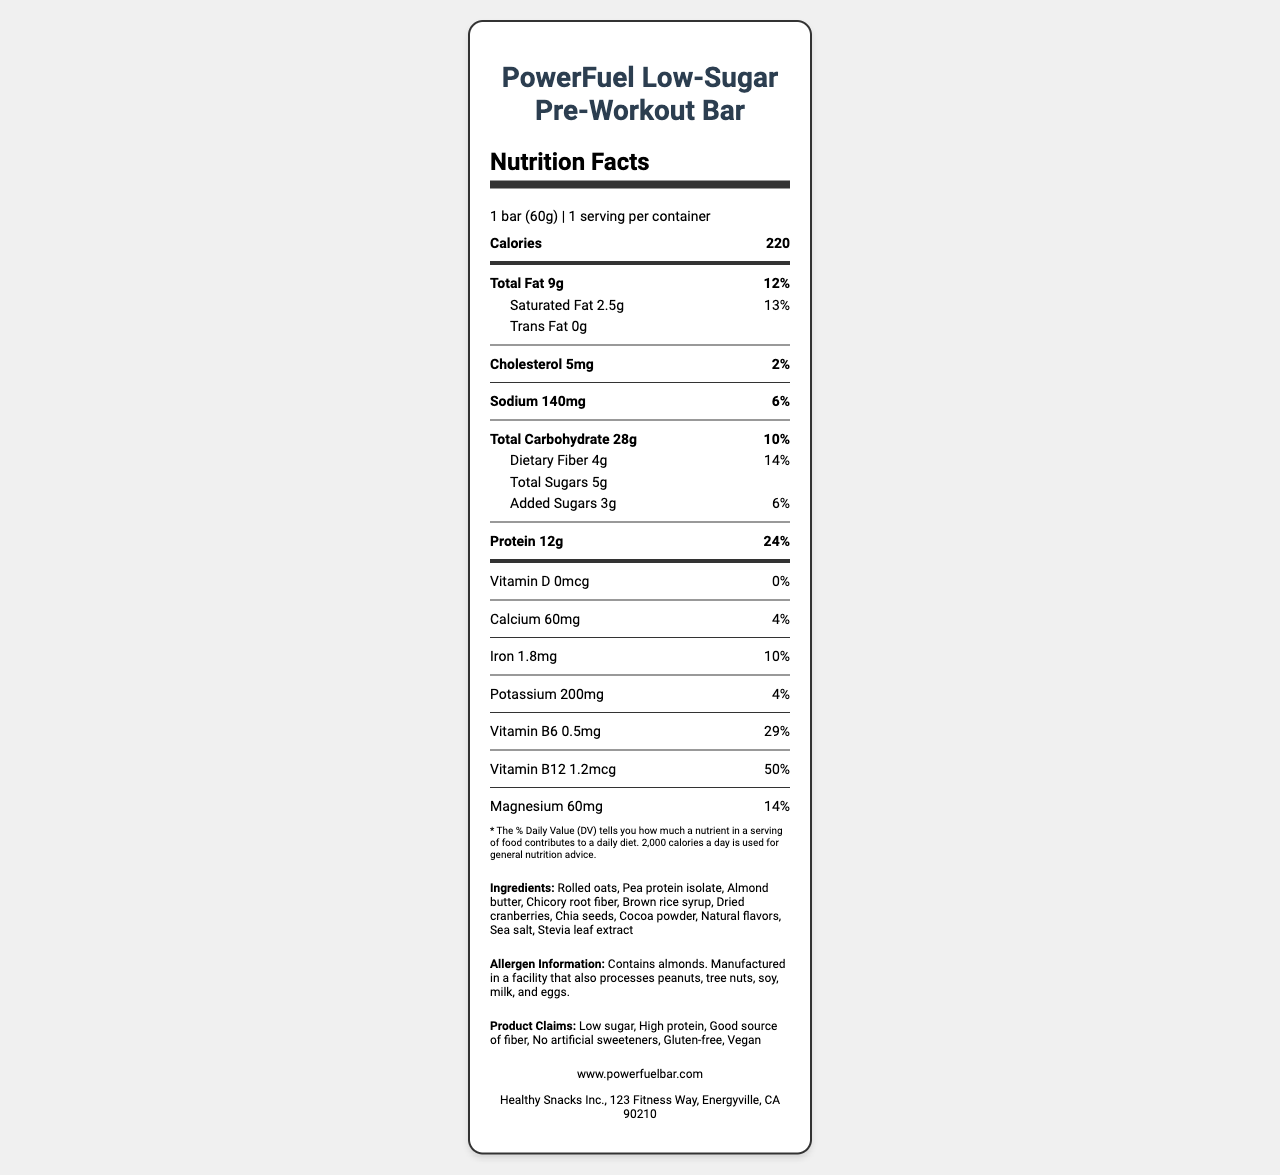what is the serving size? The serving size is specified in the document as "1 bar (60g)".
Answer: 1 bar (60g) how many calories are in one serving? The document states that there are 220 calories per serving.
Answer: 220 what is the amount of protein per serving? The document lists the protein content as 12g per serving.
Answer: 12g what percentage of the daily value for Vitamin B12 does one serving provide? According to the document, one serving provides 50% of the daily value for Vitamin B12.
Answer: 50% what are the main sources of fat in this product? The ingredients list includes almond butter and chia seeds which are common sources of fats.
Answer: Almond butter, Chia seeds which of the following is not an ingredient in the PowerFuel bar? A. Rolled oats B. Pea protein isolate C. Honey D. Stevia leaf extract Honey is not listed as an ingredient; all other options are listed.
Answer: C. Honey how much cholesterol is in one serving? A. 0mg B. 5mg C. 10mg D. 20mg The document states that one serving contains 5mg of cholesterol.
Answer: B. 5mg does the product contain any artificial sweeteners? The marketing claims specifically state "No artificial sweeteners".
Answer: No is this product gluten-free? The marketing claims include "Gluten-free".
Answer: Yes summarize the nutritional highlights of the PowerFuel Low-Sugar Pre-Workout Bar. The document shows that the product is designed to be a nutritious energy bar with low sugar, high protein, and beneficial for pre-workout consumption. It's highlighted as gluten-free, vegan, and lacking artificial sweeteners.
Answer: The PowerFuel Low-Sugar Pre-Workout Bar contains 220 calories per serving, with 9g of total fat, 28g of total carbohydrates, and 12g of protein. It's low in sugar with only 5g of total sugars, includes key vitamins and minerals like Vitamin B12 (50% DV) and Magnesium (14% DV), and is gluten-free, vegan, and contains no artificial sweeteners. does the product contain sodium? The document shows that the product contains 140mg of sodium per serving.
Answer: Yes how many grams of dietary fiber does the bar contain? The document lists 4g of dietary fiber per serving.
Answer: 4g what is the daily value percentage of iron in the PowerFuel bar? According to the document, the iron content provides 10% of the daily value.
Answer: 10% can you determine the exact source of all ingredients used? The document provides a list of ingredients, but it does not specify the exact source of each ingredient.
Answer: Cannot be determined what kind of individuals is this product targeted towards? The document specifies the target audience as fitness enthusiasts and health-conscious individuals.
Answer: Fitness enthusiasts and health-conscious individuals looking for a convenient, low-sugar energy boost before workouts 